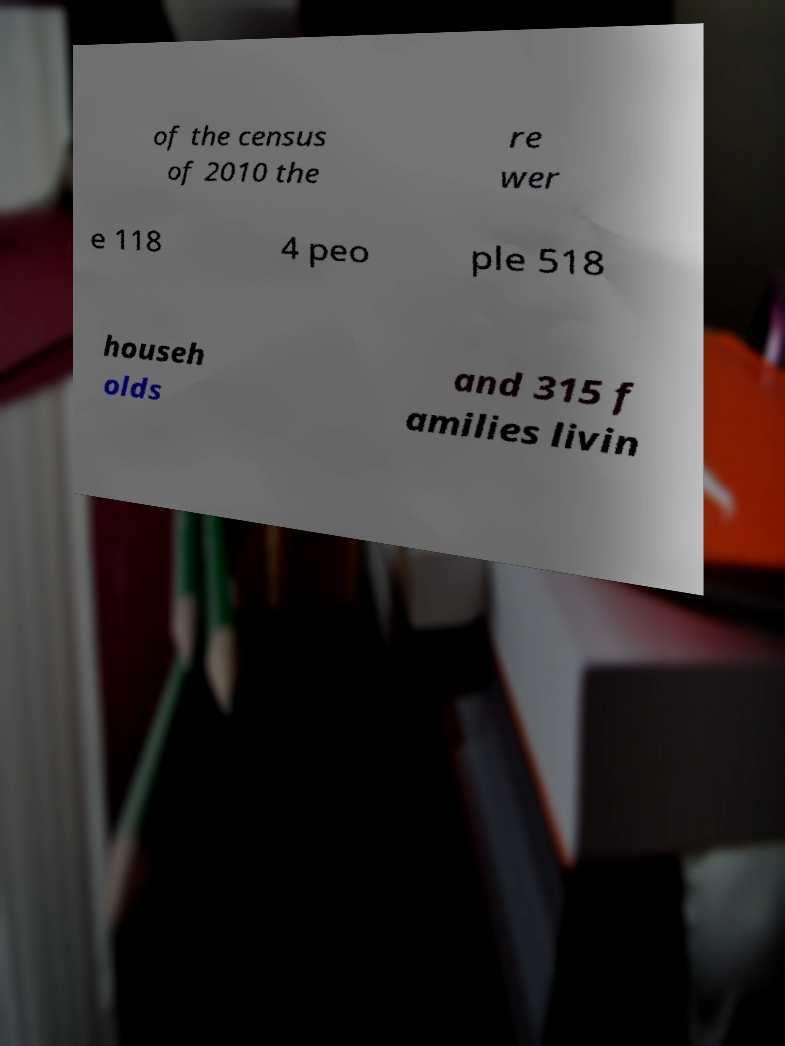For documentation purposes, I need the text within this image transcribed. Could you provide that? of the census of 2010 the re wer e 118 4 peo ple 518 househ olds and 315 f amilies livin 